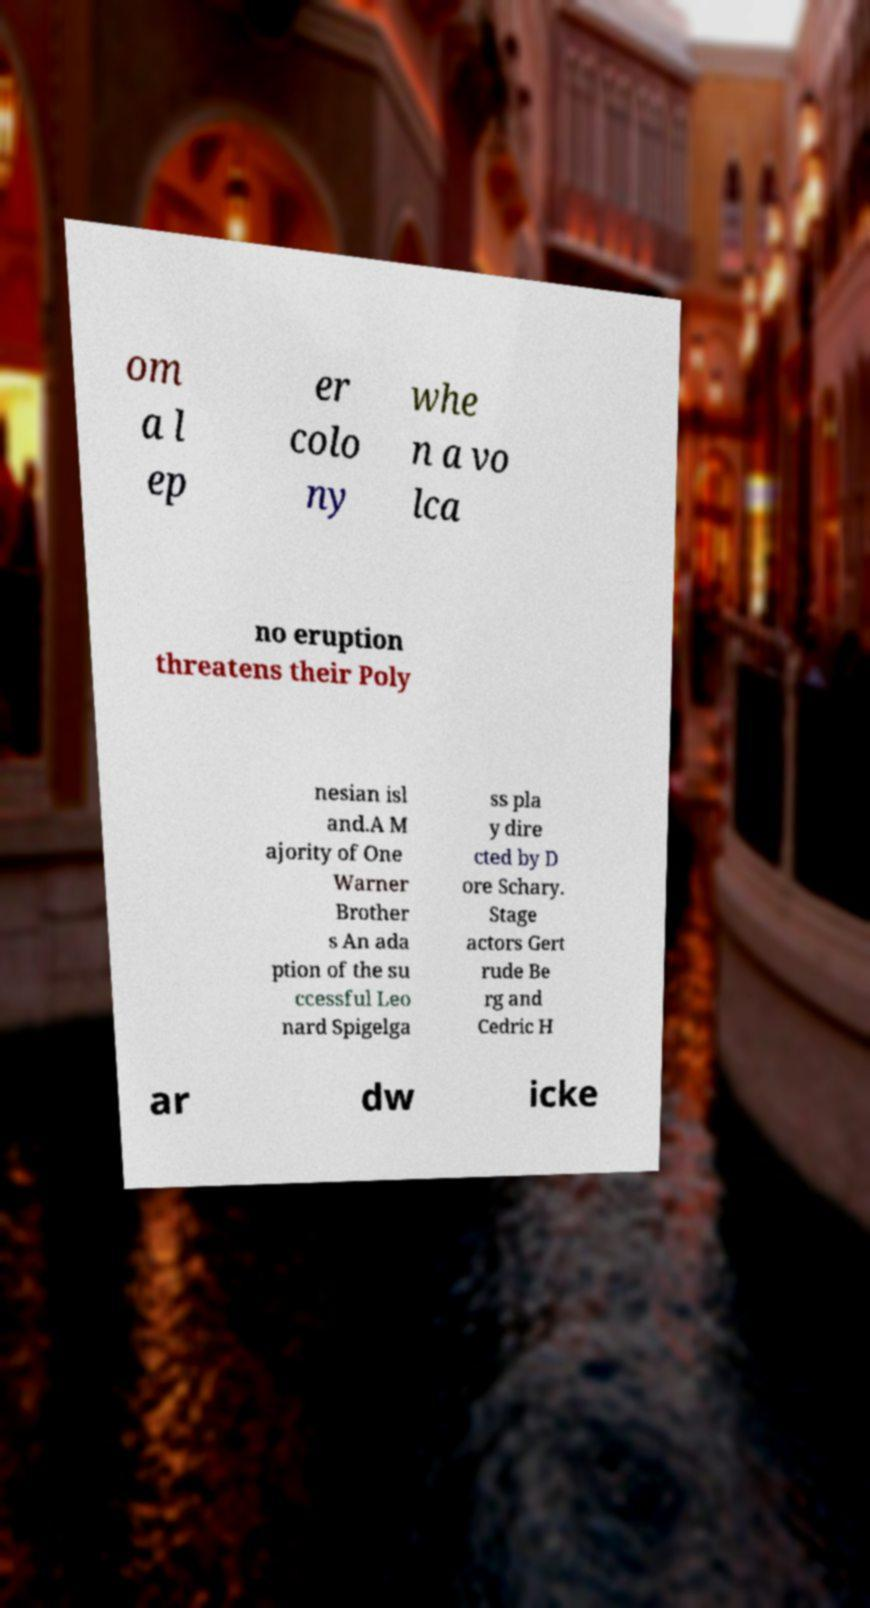What messages or text are displayed in this image? I need them in a readable, typed format. om a l ep er colo ny whe n a vo lca no eruption threatens their Poly nesian isl and.A M ajority of One Warner Brother s An ada ption of the su ccessful Leo nard Spigelga ss pla y dire cted by D ore Schary. Stage actors Gert rude Be rg and Cedric H ar dw icke 